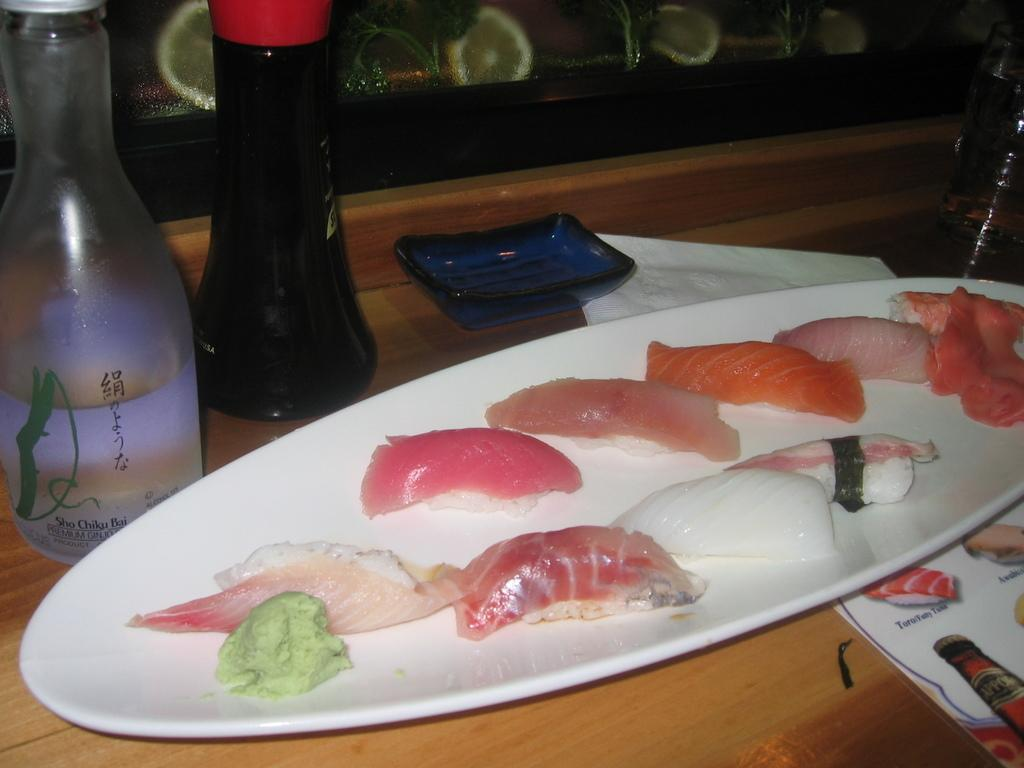What object can be seen in the image that might contain a liquid? There is a bottle and a glass in the image that might contain a liquid. What is on the plate in the image? There is meat on the plate in the image. What type of object is used for serving or displaying food? There is a plate in the image that serves this purpose. What is the paper used for in the image? The paper in the image is not specified, but it could be used for various purposes such as wrapping, writing, or serving. Where is the flame located in the image? There is no flame present in the image. What type of feast is being prepared in the image? There is no feast being prepared in the image; it only shows a plate with meat, a bottle, a glass, and a paper. 